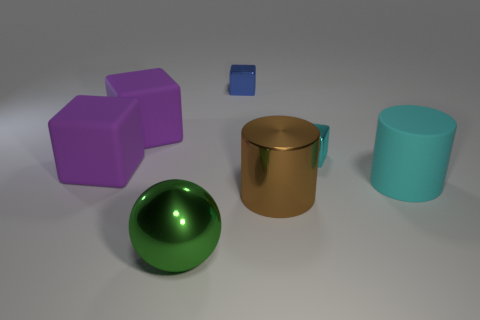There is another metallic object that is the same shape as the large cyan object; what is its color?
Offer a very short reply. Brown. Are there fewer large green spheres behind the green sphere than tiny green metallic things?
Provide a short and direct response. No. Are there any large purple rubber objects in front of the brown cylinder?
Your response must be concise. No. Are there any large brown things that have the same shape as the large cyan rubber object?
Offer a terse response. Yes. What is the shape of the blue thing that is the same size as the cyan shiny object?
Your answer should be very brief. Cube. How many things are objects left of the cyan cylinder or large shiny spheres?
Provide a succinct answer. 6. Is the color of the rubber cylinder the same as the big metal ball?
Ensure brevity in your answer.  No. What size is the matte thing to the right of the green metal object?
Your answer should be compact. Large. Are there any brown rubber cylinders of the same size as the metallic sphere?
Ensure brevity in your answer.  No. There is a shiny cube that is in front of the blue cube; is its size the same as the metallic cylinder?
Give a very brief answer. No. 